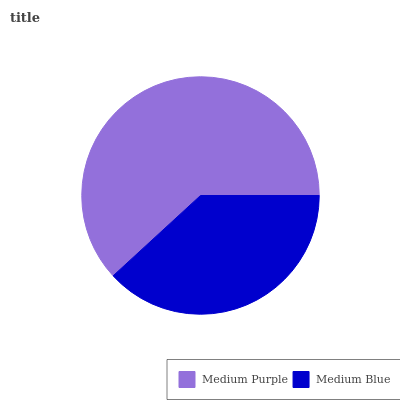Is Medium Blue the minimum?
Answer yes or no. Yes. Is Medium Purple the maximum?
Answer yes or no. Yes. Is Medium Blue the maximum?
Answer yes or no. No. Is Medium Purple greater than Medium Blue?
Answer yes or no. Yes. Is Medium Blue less than Medium Purple?
Answer yes or no. Yes. Is Medium Blue greater than Medium Purple?
Answer yes or no. No. Is Medium Purple less than Medium Blue?
Answer yes or no. No. Is Medium Purple the high median?
Answer yes or no. Yes. Is Medium Blue the low median?
Answer yes or no. Yes. Is Medium Blue the high median?
Answer yes or no. No. Is Medium Purple the low median?
Answer yes or no. No. 